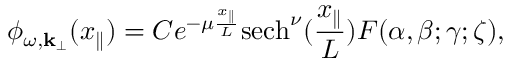<formula> <loc_0><loc_0><loc_500><loc_500>\phi _ { \omega , { k } _ { \perp } } ( x _ { \| } ) = C e ^ { - \mu \frac { x _ { \| } } { L } } s e c h ^ { \nu } ( \frac { x _ { \| } } { L } ) F ( \alpha , \beta ; \gamma ; \zeta ) ,</formula> 